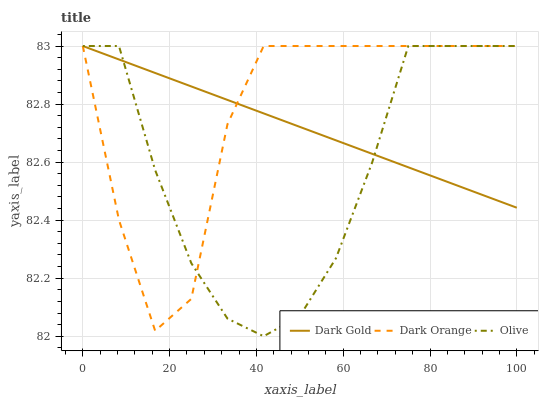Does Dark Gold have the minimum area under the curve?
Answer yes or no. No. Does Dark Gold have the maximum area under the curve?
Answer yes or no. No. Is Dark Orange the smoothest?
Answer yes or no. No. Is Dark Gold the roughest?
Answer yes or no. No. Does Dark Orange have the lowest value?
Answer yes or no. No. 